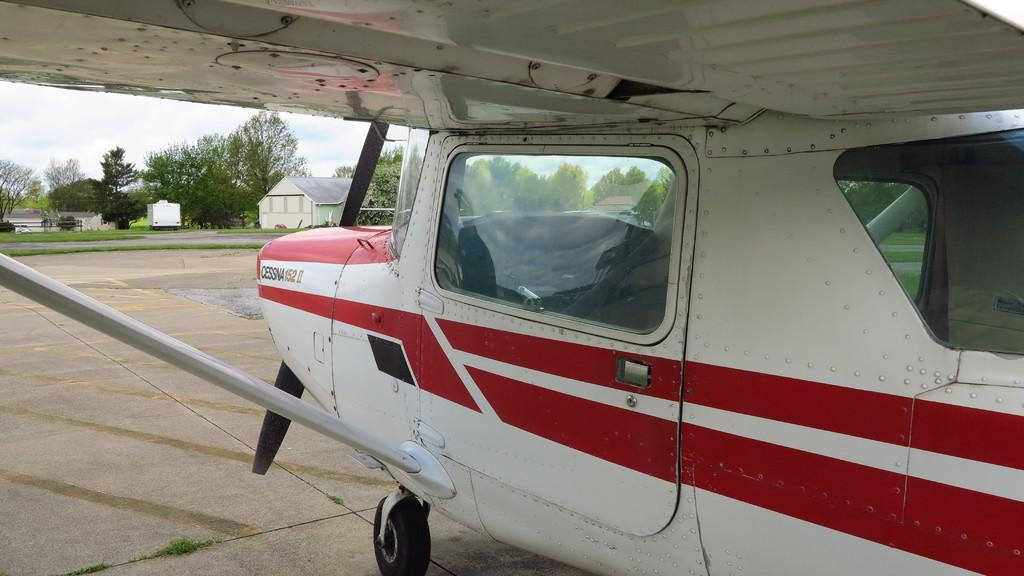What is the main subject of the image? The main subject of the image is an aircraft. What colors are used on the aircraft? The aircraft has a red and white color scheme. What can be seen in the background of the image? There are trees, buildings, and the sky visible in the background of the image. What type of balls are being played with in the image? There are no balls present in the image; it features an aircraft with a red and white color scheme in front of trees, buildings, and the sky. What religious symbols can be seen in the image? There are no religious symbols present in the image; it features an aircraft with a red and white color scheme in front of trees, buildings, and the sky. 